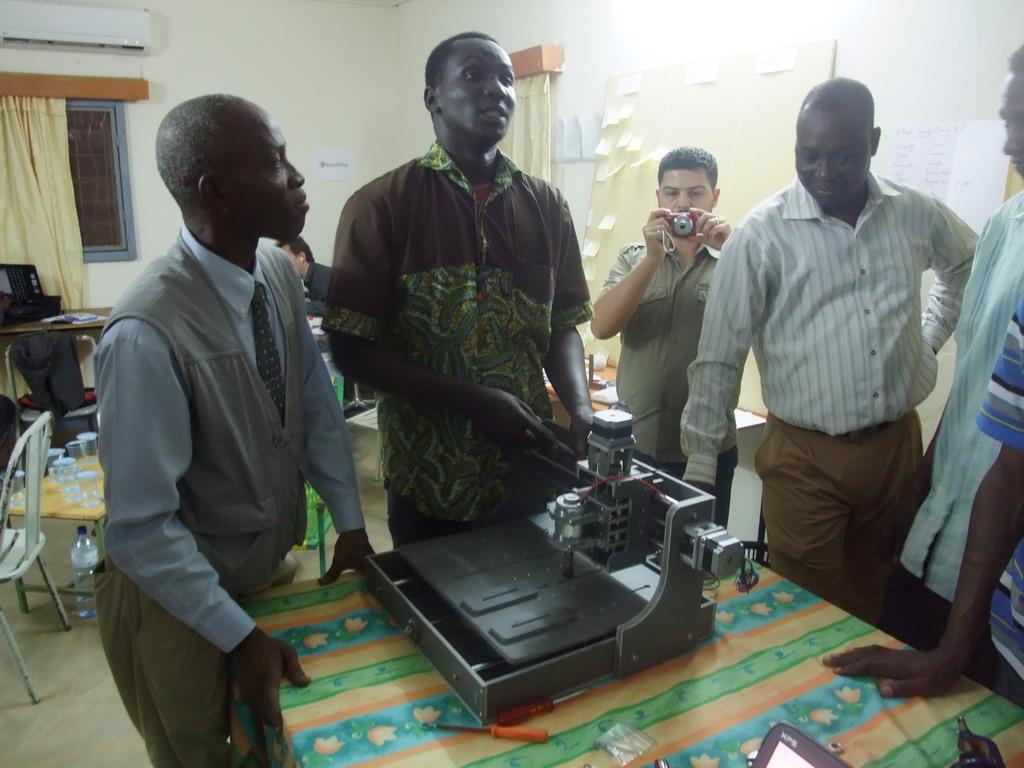Could you give a brief overview of what you see in this image? In the image there are few men standing around table with a machine on it, in the back there is a man clicking picture in , over the left side there are tables and chairs with window on the wall and ac on the top. 